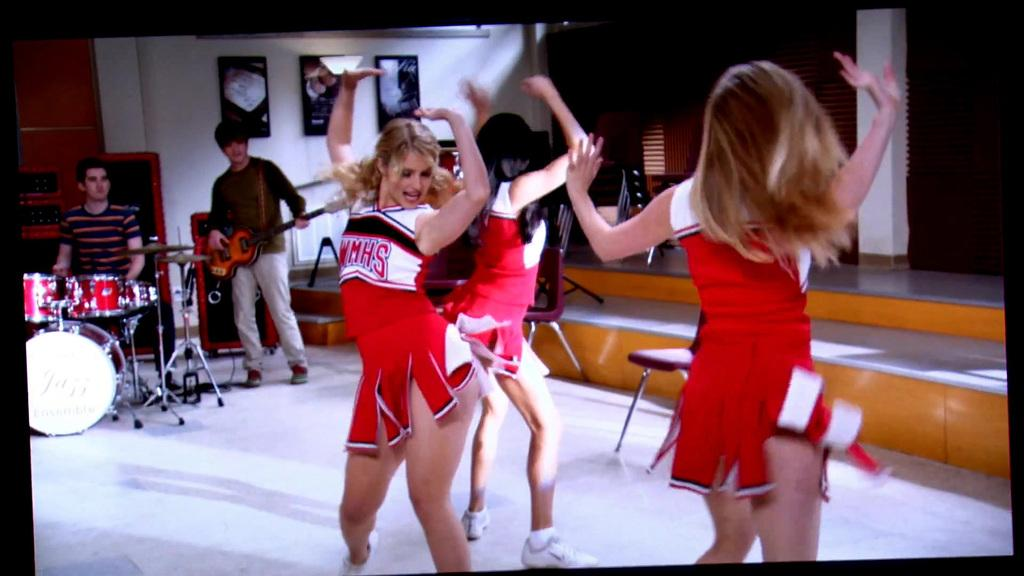<image>
Present a compact description of the photo's key features. three girls are wearing WMHS cheer outfits and are dancing 